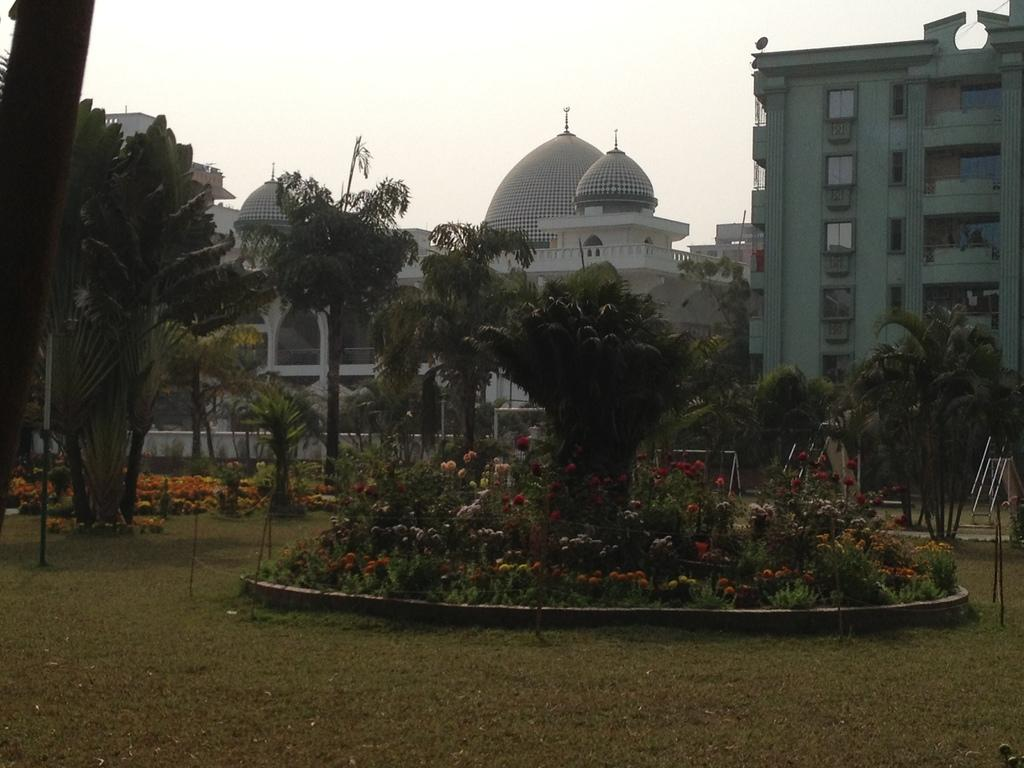What type of structures are visible in the image in the image? There are buildings with windows in the image. What architectural features can be seen on the buildings? The buildings have pillars. What type of vegetation is present in the image? There is a group of trees and plants with flowers in the image. What is the condition of the ground in the image? Grass is present in the image. What other objects can be seen in the image? There are poles in the image. How would you describe the sky in the image? The sky is visible in the image and appears cloudy. What color is the shirt worn by the van in the image? There is no van or shirt present in the image. What time of day does the image depict, considering the presence of the afternoon sun? The image does not depict a specific time of day, and there is no mention of the afternoon sun. 